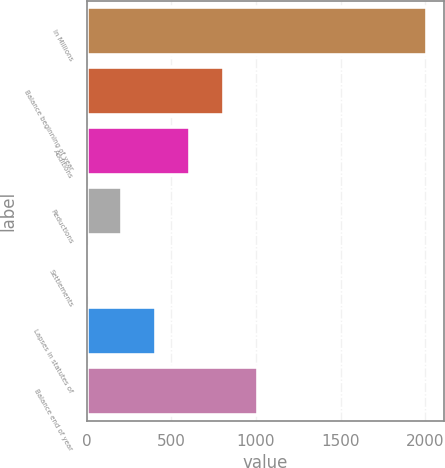<chart> <loc_0><loc_0><loc_500><loc_500><bar_chart><fcel>In Millions<fcel>Balance beginning of year<fcel>Additions<fcel>Reductions<fcel>Settlements<fcel>Lapses in statutes of<fcel>Balance end of year<nl><fcel>2012<fcel>808.76<fcel>608.22<fcel>207.14<fcel>6.6<fcel>407.68<fcel>1009.3<nl></chart> 